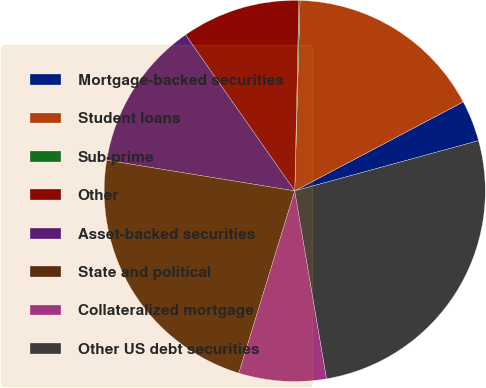<chart> <loc_0><loc_0><loc_500><loc_500><pie_chart><fcel>Mortgage-backed securities<fcel>Student loans<fcel>Sub-prime<fcel>Other<fcel>Asset-backed securities<fcel>State and political<fcel>Collateralized mortgage<fcel>Other US debt securities<nl><fcel>3.49%<fcel>16.82%<fcel>0.1%<fcel>10.06%<fcel>12.71%<fcel>22.83%<fcel>7.41%<fcel>26.58%<nl></chart> 